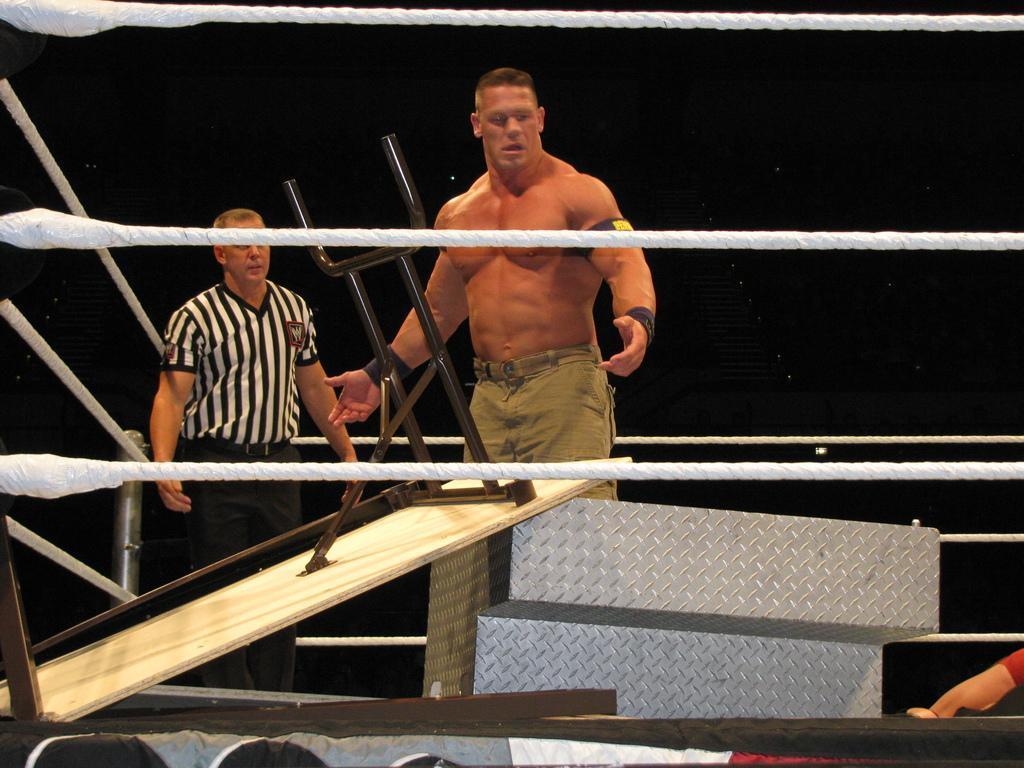Can you describe this image briefly? In this image we can see a boxing court. In the boxing court, we can see a table, stairs and three people. The background is dark. 